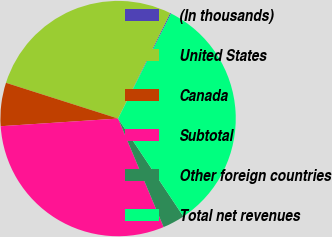Convert chart. <chart><loc_0><loc_0><loc_500><loc_500><pie_chart><fcel>(In thousands)<fcel>United States<fcel>Canada<fcel>Subtotal<fcel>Other foreign countries<fcel>Total net revenues<nl><fcel>0.14%<fcel>27.38%<fcel>5.95%<fcel>30.29%<fcel>3.04%<fcel>33.2%<nl></chart> 